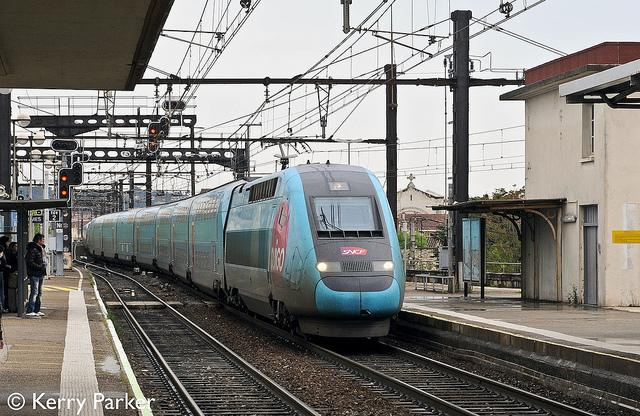The main color of this vehicle is the same color as what?

Choices:
A) grass
B) flamingo
C) daisy
D) sky sky 